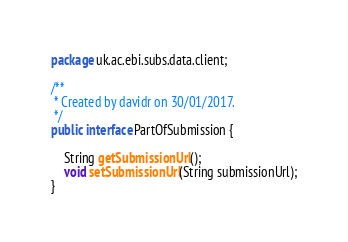<code> <loc_0><loc_0><loc_500><loc_500><_Java_>package uk.ac.ebi.subs.data.client;

/**
 * Created by davidr on 30/01/2017.
 */
public interface PartOfSubmission {

    String getSubmissionUrl();
    void setSubmissionUrl(String submissionUrl);
}
</code> 